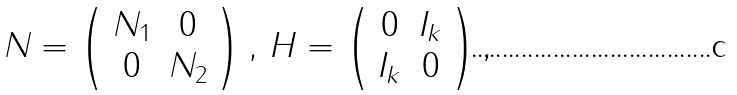Convert formula to latex. <formula><loc_0><loc_0><loc_500><loc_500>N = \left ( \begin{array} { c c } N _ { 1 } & 0 \\ 0 & N _ { 2 } \end{array} \right ) , \, H = \left ( \begin{array} { c c } 0 & I _ { k } \\ I _ { k } & 0 \end{array} \right ) ,</formula> 